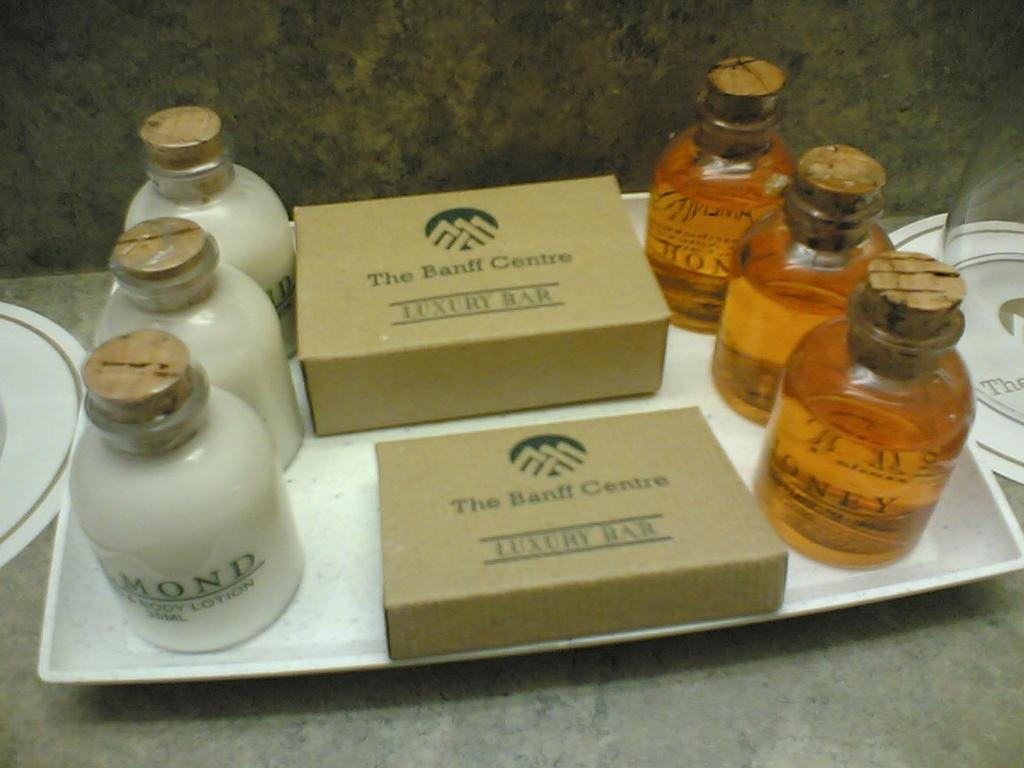<image>
Create a compact narrative representing the image presented. A tray of bathroom amenities is offered by the Banff Centre. 